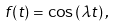Convert formula to latex. <formula><loc_0><loc_0><loc_500><loc_500>f ( t ) = \cos \left ( \lambda t \right ) ,</formula> 